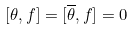<formula> <loc_0><loc_0><loc_500><loc_500>[ \theta , f ] = [ \overline { \theta } , f ] = 0</formula> 